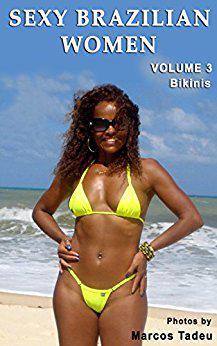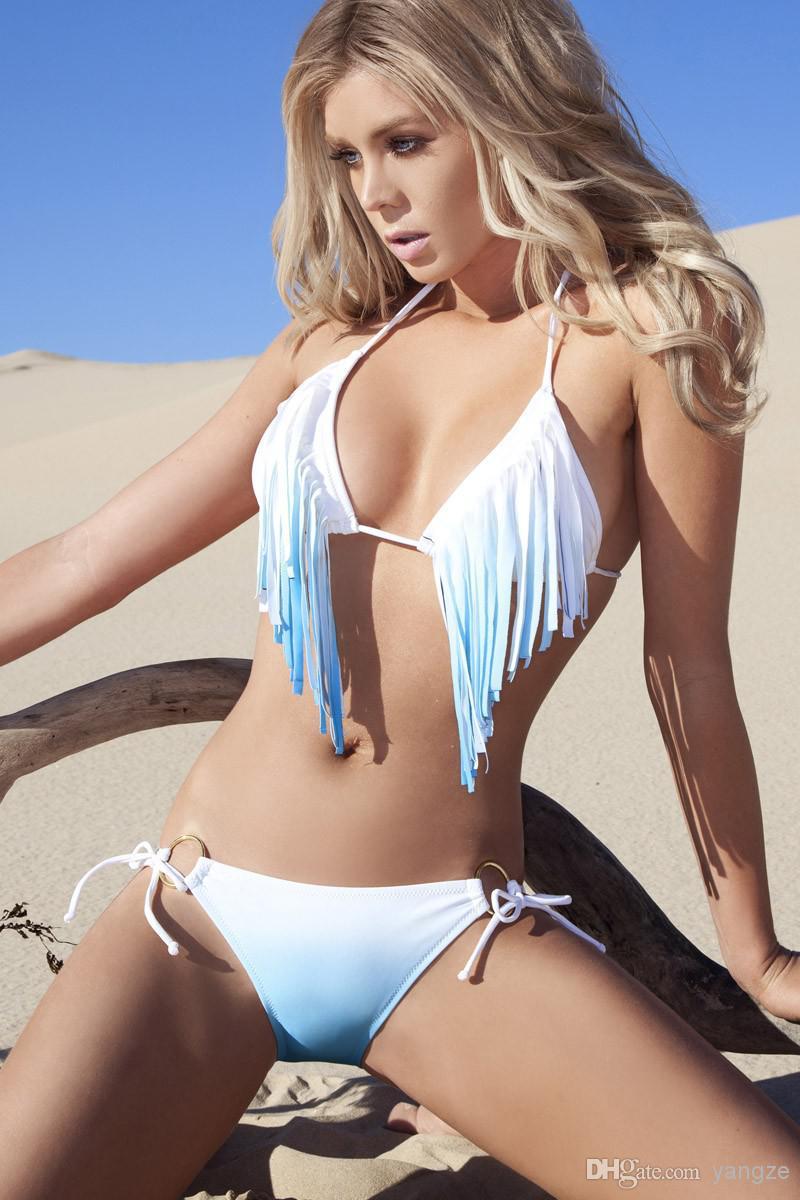The first image is the image on the left, the second image is the image on the right. Considering the images on both sides, is "There is at least two females in a bikini in the right image." valid? Answer yes or no. No. The first image is the image on the left, the second image is the image on the right. Assess this claim about the two images: "An image shows three models in different bikini colors.". Correct or not? Answer yes or no. No. 